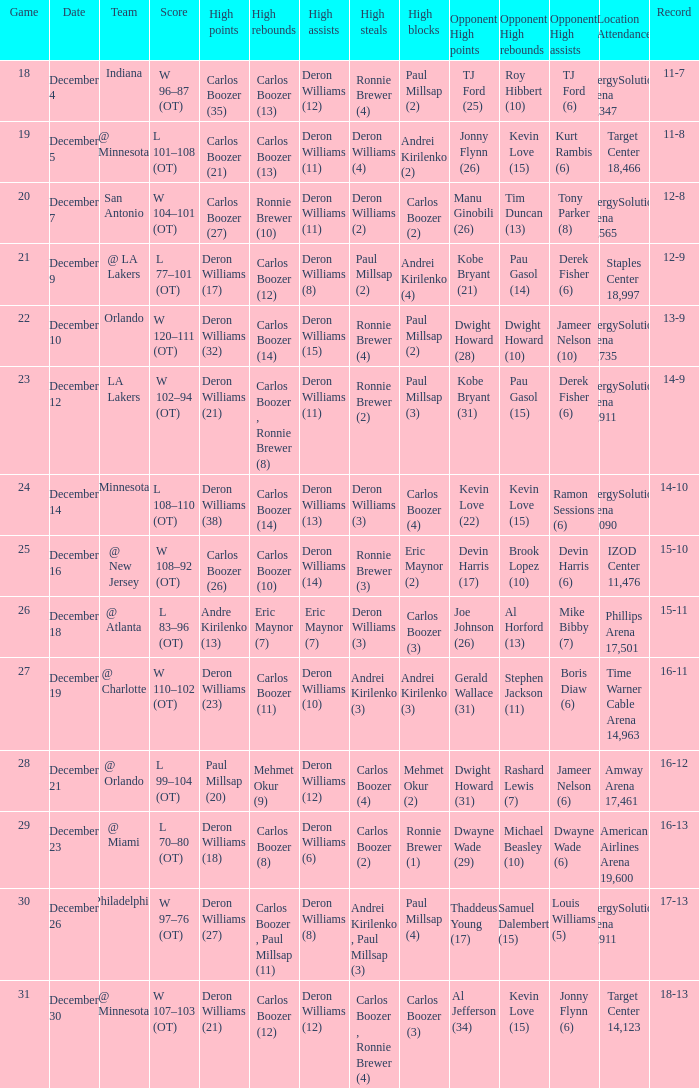How many different high rebound results are there for the game number 26? 1.0. 